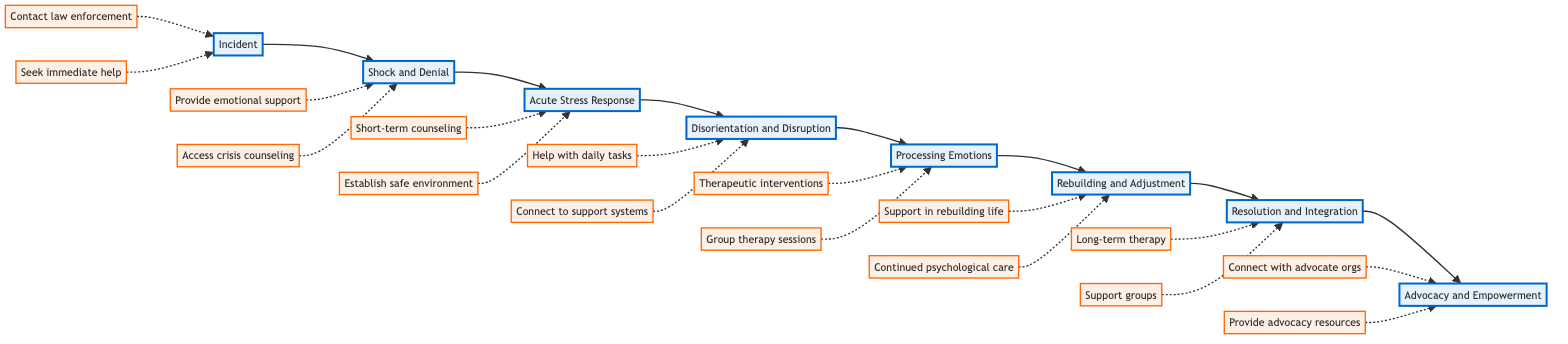What is the first stage in the recovery timeline? The diagram shows that the first stage is "Incident," which is where the crime occurs and the victim begins to experience emotional trauma.
Answer: Incident How many total stages are depicted in the flowchart? By counting all the distinct stages listed in the flowchart, we find there are eight stages from "Incident" to "Advocacy and Empowerment."
Answer: 8 What type of support is recommended during the "Shock and Denial" stage? The actions for this stage include "Provide emotional support" and "Access crisis counseling," indicating the focus on providing immediate emotional assistance.
Answer: Emotional support What stage follows "Processing Emotions"? In the flowchart, after "Processing Emotions," the next stage is "Rebuilding and Adjustment." This can be identified by looking at the directional connection in the diagram.
Answer: Rebuilding and Adjustment What actions are suggested during the "Acute Stress Response"? The flowchart lists "Short-term counseling" and "Establish safe environment" as actions to be taken during this stage. Looking at the actions connected to the respective stage confirms these recommendations.
Answer: Short-term counseling; Establish safe environment Which stage incorporates victim advocacy? The last stage, "Advocacy and Empowerment," relates to victim advocacy as it discusses victims potentially becoming advocates for crime victims' rights through various connections and resources provided.
Answer: Advocacy and Empowerment Which stage comes before "Disorientation and Disruption"? Tracing the flow, "Acute Stress Response" leads directly into "Disorientation and Disruption." This is clearly indicated by the flowchart's directional arrows connecting the stages.
Answer: Acute Stress Response What type of therapy is emphasized during the "Processing Emotions" stage? The actions specified for this stage include "Therapeutic interventions such as Cognitive Behavioral Therapy" and "Group therapy sessions," highlighting the importance of mental health support.
Answer: Cognitive Behavioral Therapy; Group therapy sessions 